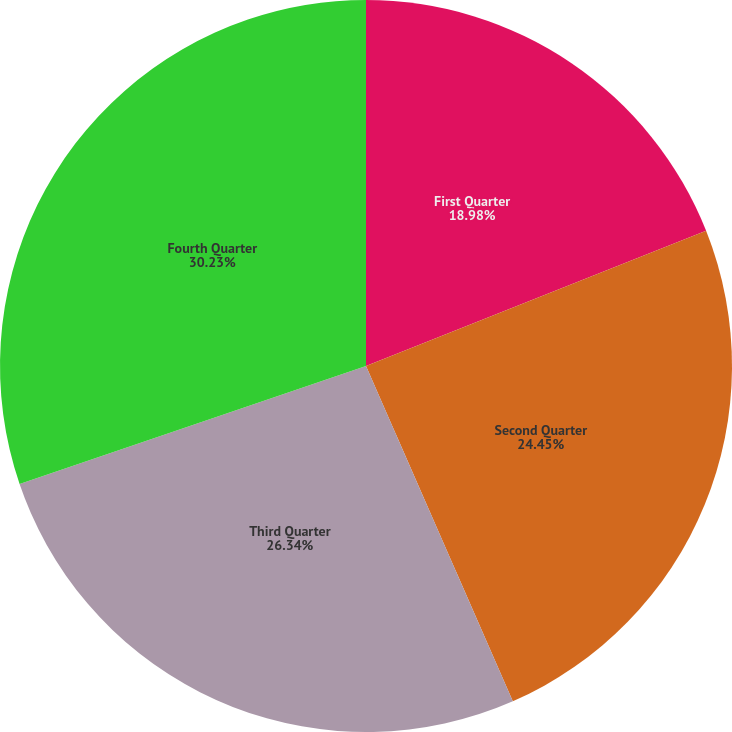Convert chart. <chart><loc_0><loc_0><loc_500><loc_500><pie_chart><fcel>First Quarter<fcel>Second Quarter<fcel>Third Quarter<fcel>Fourth Quarter<nl><fcel>18.98%<fcel>24.45%<fcel>26.34%<fcel>30.23%<nl></chart> 